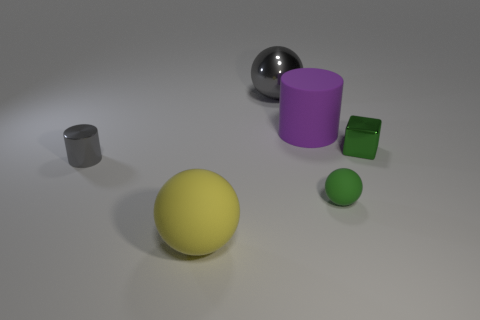Subtract all matte balls. How many balls are left? 1 Subtract all red spheres. How many gray cylinders are left? 1 Add 3 big spheres. How many big spheres are left? 5 Add 1 big purple cylinders. How many big purple cylinders exist? 2 Add 4 big matte objects. How many objects exist? 10 Subtract all gray cylinders. How many cylinders are left? 1 Subtract 1 gray cylinders. How many objects are left? 5 Subtract all cylinders. How many objects are left? 4 Subtract 1 cubes. How many cubes are left? 0 Subtract all cyan cylinders. Subtract all gray cubes. How many cylinders are left? 2 